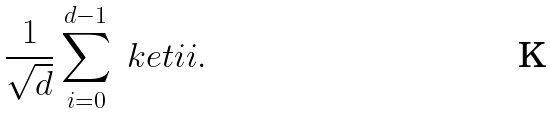<formula> <loc_0><loc_0><loc_500><loc_500>\frac { 1 } { \sqrt { d } } \sum _ { i = 0 } ^ { d - 1 } \ k e t { i i } .</formula> 